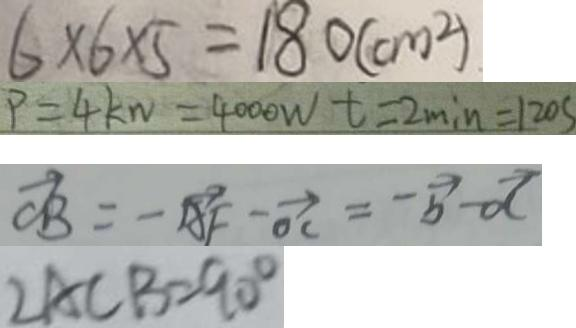Convert formula to latex. <formula><loc_0><loc_0><loc_500><loc_500>6 \times 6 \times 5 = 1 8 0 ( c m ^ { 2 } ) 
 P = 4 k w = 4 0 0 0 W t = 2 \min = 1 2 0 s 
 \overrightarrow { C B } = - \overrightarrow { A F } - \overrightarrow { O C } = - \overrightarrow { b } - \overrightarrow { d } 
 \angle A C B = 9 0 ^ { \circ }</formula> 